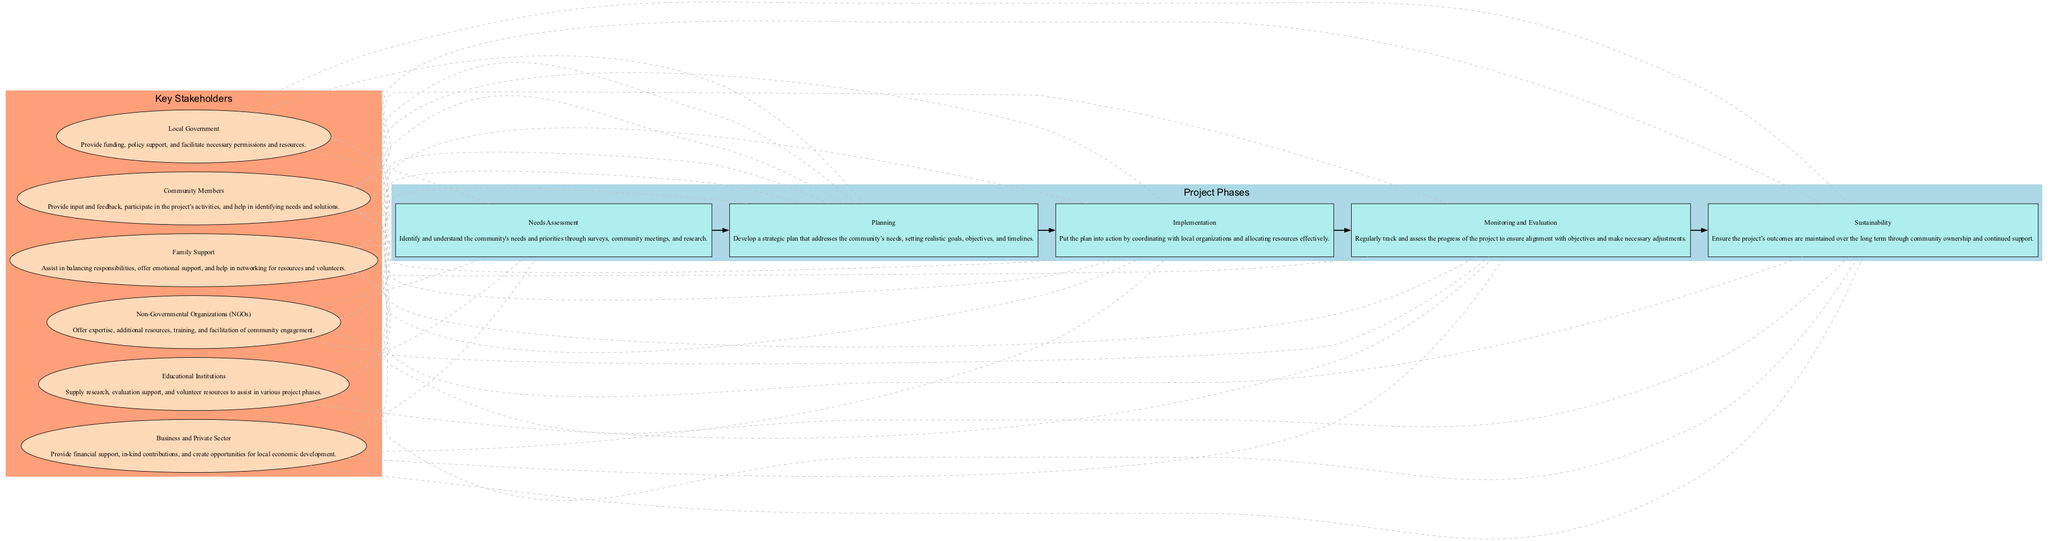What are the five project phases? The five project phases listed in the diagram are Needs Assessment, Planning, Implementation, Monitoring and Evaluation, and Sustainability. These can be identified directly from the cluster labeled "Project Phases."
Answer: Needs Assessment, Planning, Implementation, Monitoring and Evaluation, Sustainability How many key stakeholders are identified in the diagram? The diagram includes a cluster labeled "Key Stakeholders" that lists six stakeholders. Counting each stakeholder node within this cluster confirms the total number.
Answer: Six What is the role of Local Government? By examining the node for Local Government in the key stakeholders section, the description indicates that it provides funding, policy support, and facilitates necessary permissions and resources.
Answer: Provide funding, policy support, and facilitate necessary permissions and resources Which phase comes after Planning? In the project phases cluster, the phases are sequentially connected with edges. The edge from Planning leads to the next phase, which is Implementation. This can be determined by the order of the phases in the diagram.
Answer: Implementation What type of edge connects stakeholders to project phases? The edges that connect the stakeholders to the project phases are described as dashed, indicating a non-directional relationship, signifying collaboration or engagement rather than a direct cause-effect relationship.
Answer: Dashed Who provides training and expertise in the project? The node for Non-Governmental Organizations (NGOs) states that they offer expertise, additional resources, training, and facilitate community engagement. This role clearly identifies NGOs as the key source of training and expertise for the project.
Answer: Non-Governmental Organizations (NGOs) Which phase is focused on tracking project progress? The phase that centers on tracking and assessing the project's progress is labeled Monitoring and Evaluation. This is explicitly detailed in the project phases cluster and follows the Implementation phase.
Answer: Monitoring and Evaluation What is a key role of Community Members? Looking at the Community Members node, they provide input and feedback, participate in the project's activities, and help in identifying needs and solutions which highlights their active involvement in the project.
Answer: Provide input and feedback, participate in the project's activities, and help in identifying needs and solutions What connects the stakeholders to the Monitoring and Evaluation phase? The diagram shows a dashed edge connecting every stakeholder to the Monitoring and Evaluation phase, indicating collaboration that might affect or contribute to the monitoring and evaluation process. This suggests a mutual relationship where stakeholders input is crucial for evaluation.
Answer: Dashed edge 